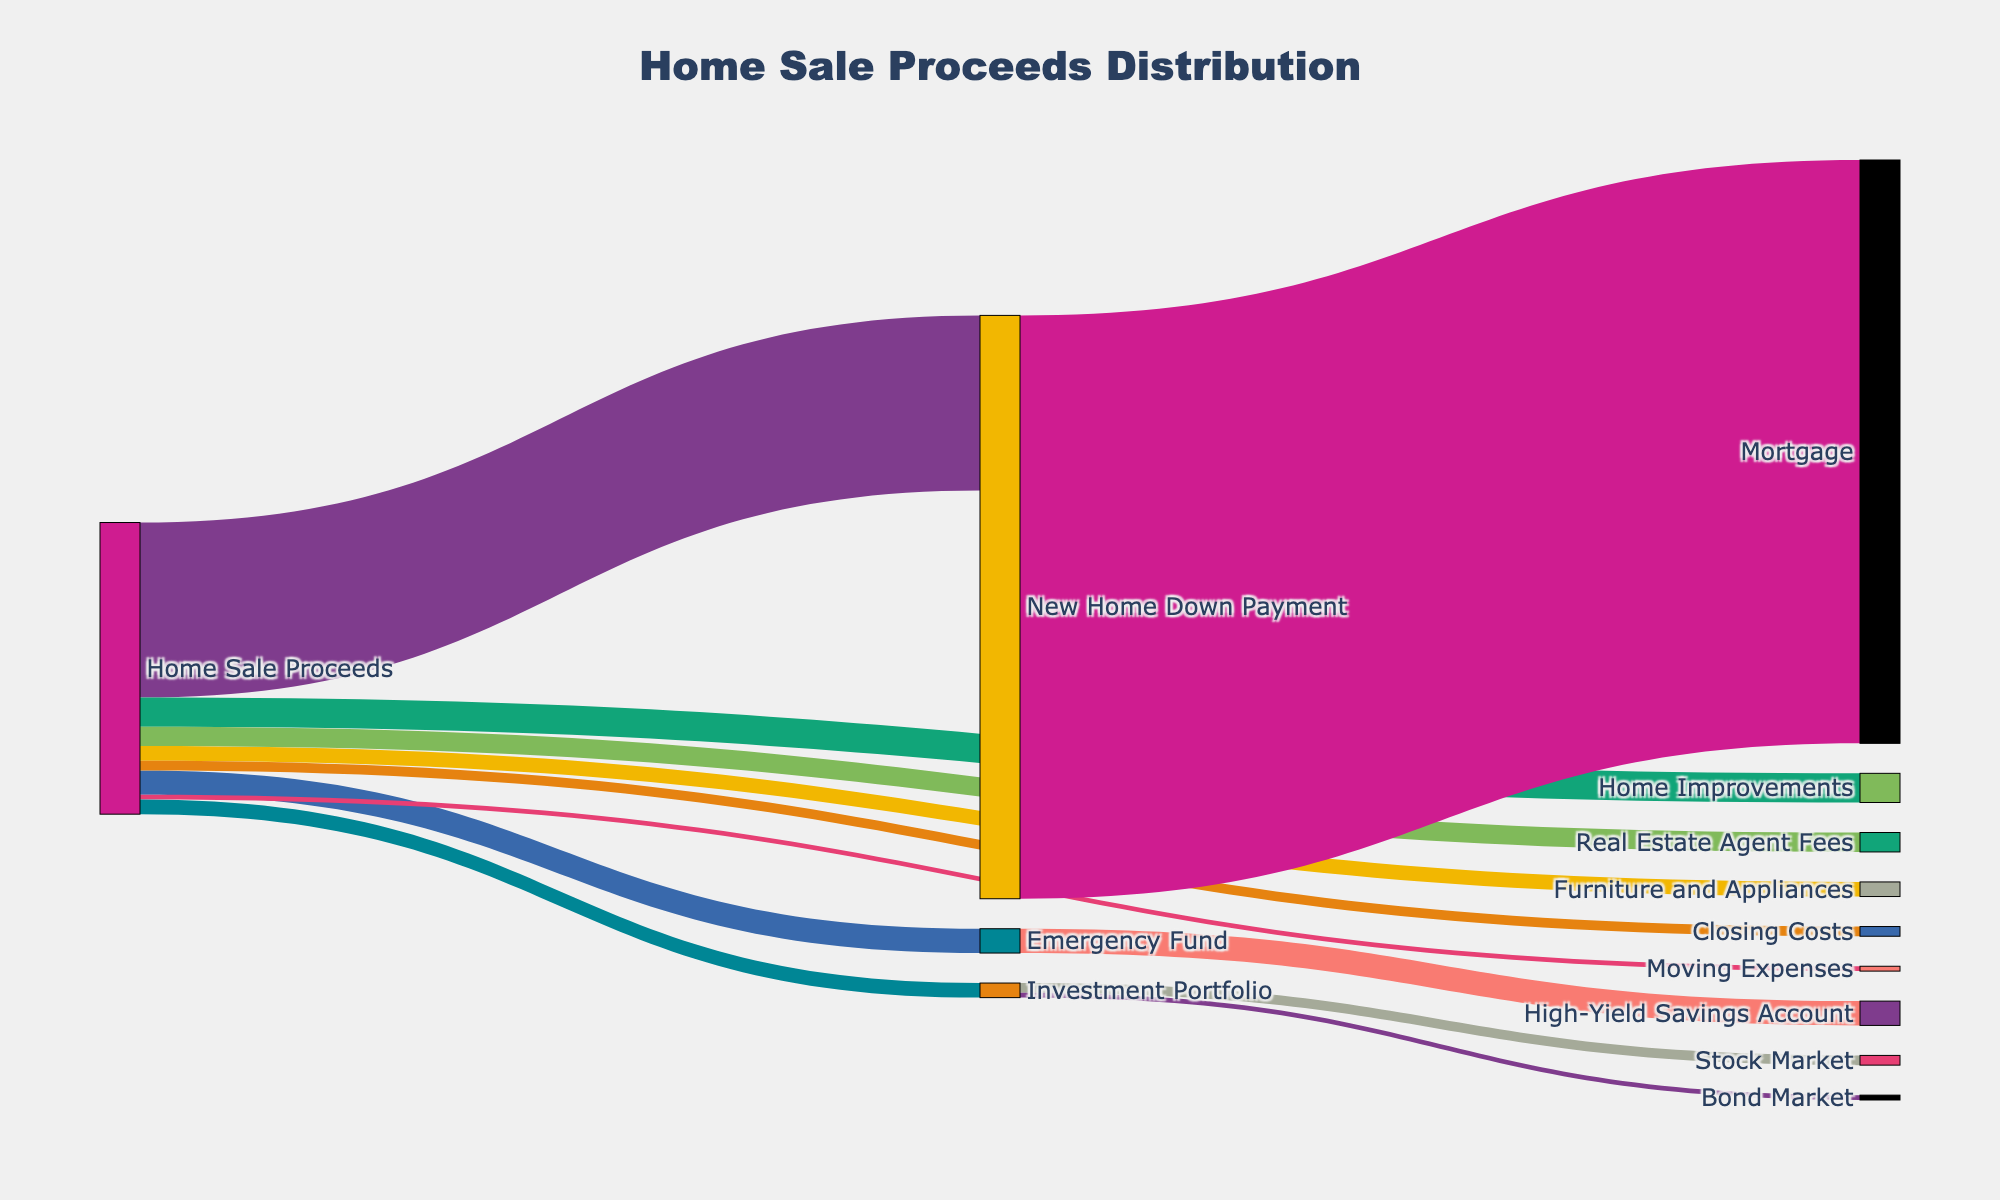What is the exact amount allocated to the New Home Down Payment? The Sankey Diagram indicates the specific monetary flows from the Home Sale Proceeds. Following the link from Home Sale Proceeds to New Home Down Payment shows the allocated amount.
Answer: $180,000 Which expense category received the least amount from the Home Sale Proceeds? By looking at the Sankey Diagram, identify the smallest flow line from Home Sale Proceeds to different target nodes. This flow represents the smallest monetary allocation.
Answer: Moving Expenses How much total money is allocated to savings (Emergency Fund and Investment Portfolio combined)? Follow the flows from Home Sale Proceeds to both the Emergency Fund and Investment Portfolio. Add the two values together: $25,000 (Emergency Fund) + $15,000 (Investment Portfolio).
Answer: $40,000 Compare the amount allocated for Home Improvements against the Investment Portfolio. Which is greater and by how much? Find the values for Home Improvements and Investment Portfolio from the figure. The Home Improvements value is $30,000 and the Investment Portfolio is $15,000. Subtract the smaller value from the larger value: $30,000 - $15,000.
Answer: Home Improvements by $15,000 What is the total amount allocated to different expenses excluding the New Home Down Payment? Identify all the separate flows from Home Sale Proceeds to the various targets except the New Home Down Payment. Sum these values: $30,000 (Home Improvements) + $25,000 (Emergency Fund) + $15,000 (Furniture and Appliances) + $5,000 (Moving Expenses) + $20,000 (Real Estate Agent Fees) + $10,000 (Closing Costs) + $15,000 (Investment Portfolio).
Answer: $120,000 Where is the Emergency Fund allocated, and what is its destination value? Follow the flow line from Emergency Fund to its target, which shows where the money is moved next. The figure reveals the allocation.
Answer: High-Yield Savings Account with $25,000 How does the amount allocated to Real Estate Agent Fees compare to Furniture and Appliances? Look at the values of both allocations in the Sankey Diagram. Real Estate Agent Fees is $20,000 and Furniture and Appliances is $15,000. Compare the two values to see which is higher.
Answer: Real Estate Agent Fees is $5,000 higher Which targets receive allocations directly from the Investment Portfolio, and what are their respective values? Track the flows from Investment Portfolio to its corresponding targets. The diagram shows separate flows leading to Stock Market and Bond Market along with their respective values. Add these values together: $10,000 (Stock Market) + $5,000 (Bond Market).
Answer: Stock Market with $10,000 and Bond Market with $5,000 If you exclude the New Home Down Payment, which category received the highest allocation, and how much is it? From the Home Sale Proceeds, identify which of the remaining categories has the highest single value. Observe the diagram to determine the highest allocation excluding New Home Down Payment.
Answer: Home Improvements with $30,000 